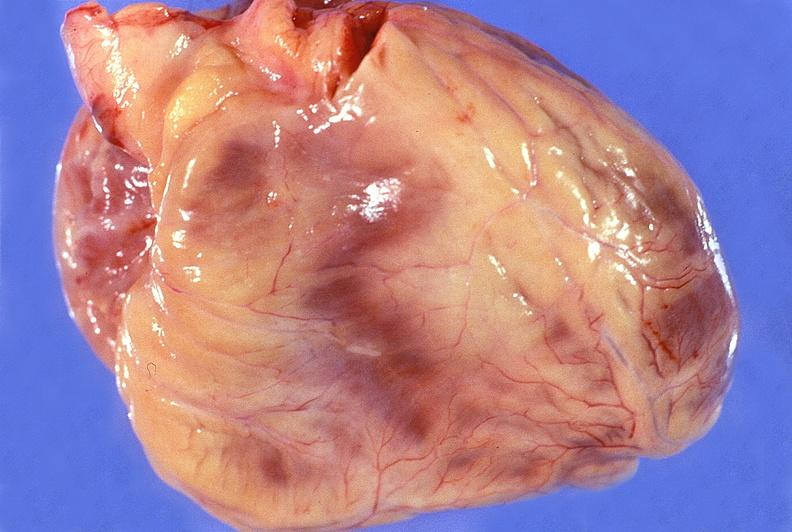where is this?
Answer the question using a single word or phrase. Heart 